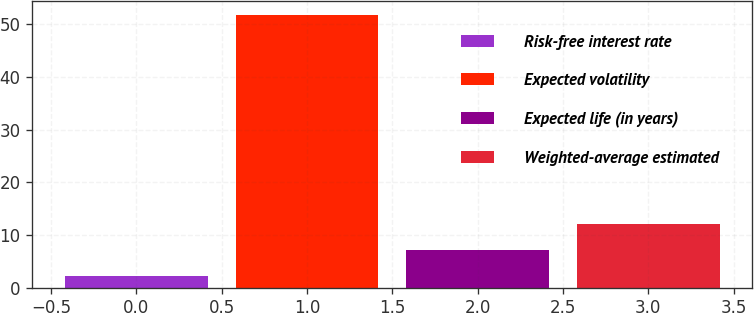Convert chart. <chart><loc_0><loc_0><loc_500><loc_500><bar_chart><fcel>Risk-free interest rate<fcel>Expected volatility<fcel>Expected life (in years)<fcel>Weighted-average estimated<nl><fcel>2.18<fcel>51.75<fcel>7.14<fcel>12.1<nl></chart> 